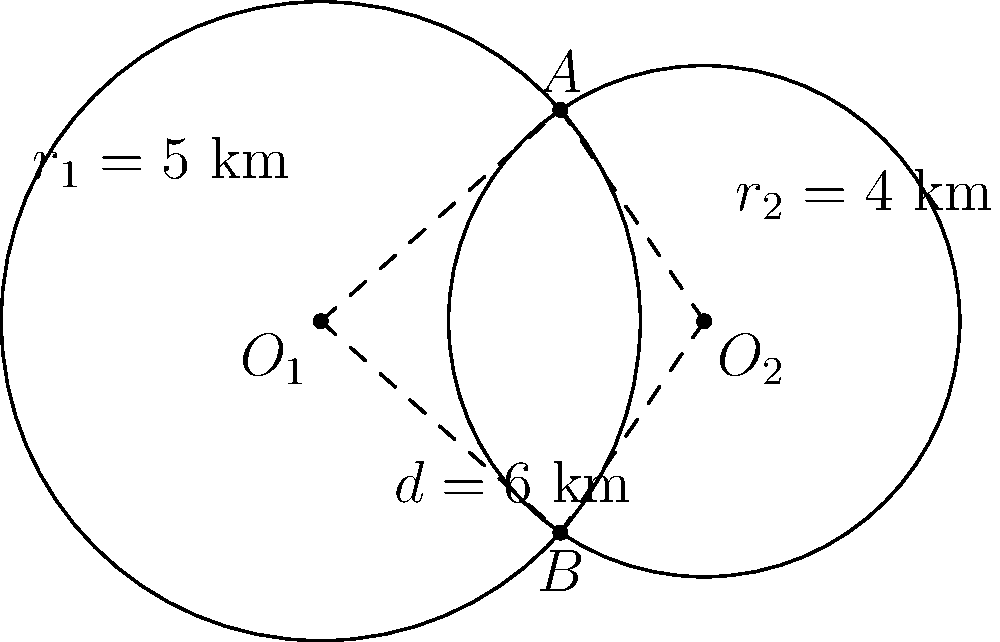Two circular drilling zones are represented by the circles shown in the figure. The centers of the circles, $O_1$ and $O_2$, are 6 km apart. The radius of the larger circle (centered at $O_1$) is 5 km, while the radius of the smaller circle (centered at $O_2$) is 4 km. Calculate the area of the overlapping region between these two drilling zones. To find the area of the overlapping region, we need to follow these steps:

1) First, we need to find the distance from the center of each circle to the line connecting the intersection points A and B. Let's call this distance h. We can find h using the Pythagorean theorem:

   For the larger circle: $h_1^2 + (\frac{d}{2})^2 = r_1^2$
   For the smaller circle: $h_2^2 + (\frac{d}{2})^2 = r_2^2$

   Where d is the distance between the centers (6 km).

2) Solving for $h_1$ and $h_2$:

   $h_1 = \sqrt{r_1^2 - (\frac{d}{2})^2} = \sqrt{5^2 - 3^2} = 4$ km
   $h_2 = \sqrt{r_2^2 - (\frac{d}{2})^2} = \sqrt{4^2 - 3^2} = \sqrt{7}$ km

3) Now, we can calculate the central angles for each sector:

   $\theta_1 = 2 \arccos(\frac{3}{5})$ radians
   $\theta_2 = 2 \arccos(\frac{3}{4})$ radians

4) The area of each sector is:

   $A_1 = \frac{1}{2} r_1^2 \theta_1 = \frac{1}{2} (5^2) (2 \arccos(\frac{3}{5}))$ km²
   $A_2 = \frac{1}{2} r_2^2 \theta_2 = \frac{1}{2} (4^2) (2 \arccos(\frac{3}{4}))$ km²

5) The area of each triangle is:

   $A_{t1} = \frac{1}{2} (3)(4) = 6$ km²
   $A_{t2} = \frac{1}{2} (3)(\sqrt{7}) = \frac{3\sqrt{7}}{2}$ km²

6) The overlapping area is the sum of the sectors minus the sum of the triangles:

   $A_{overlap} = (A_1 + A_2) - (A_{t1} + A_{t2})$

7) Substituting the values:

   $A_{overlap} = [5^2 \arccos(\frac{3}{5}) + 4^2 \arccos(\frac{3}{4})] - [6 + \frac{3\sqrt{7}}{2}]$

8) Calculating this gives us approximately 10.82 km².
Answer: 10.82 km² 